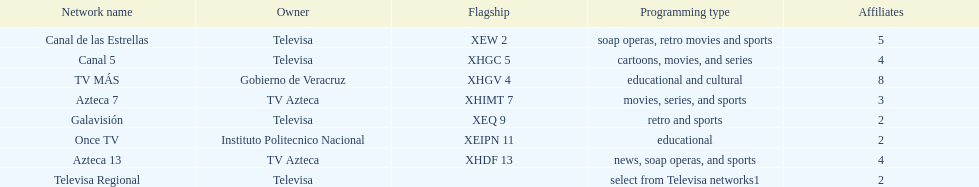How many networks have more partners than canal de las estrellas? 1. 